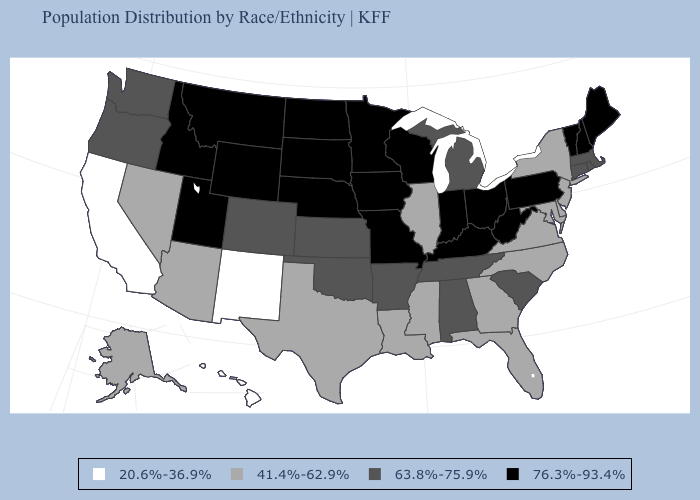Name the states that have a value in the range 41.4%-62.9%?
Answer briefly. Alaska, Arizona, Delaware, Florida, Georgia, Illinois, Louisiana, Maryland, Mississippi, Nevada, New Jersey, New York, North Carolina, Texas, Virginia. What is the highest value in the USA?
Be succinct. 76.3%-93.4%. Does the first symbol in the legend represent the smallest category?
Quick response, please. Yes. What is the value of Kentucky?
Be succinct. 76.3%-93.4%. Does Washington have the highest value in the USA?
Answer briefly. No. Does North Dakota have the highest value in the USA?
Short answer required. Yes. Which states have the lowest value in the USA?
Short answer required. California, Hawaii, New Mexico. Name the states that have a value in the range 41.4%-62.9%?
Quick response, please. Alaska, Arizona, Delaware, Florida, Georgia, Illinois, Louisiana, Maryland, Mississippi, Nevada, New Jersey, New York, North Carolina, Texas, Virginia. What is the value of Illinois?
Give a very brief answer. 41.4%-62.9%. Does Maryland have a higher value than Rhode Island?
Answer briefly. No. Among the states that border Nebraska , does Wyoming have the lowest value?
Concise answer only. No. Among the states that border Kentucky , does West Virginia have the lowest value?
Give a very brief answer. No. What is the value of Iowa?
Answer briefly. 76.3%-93.4%. Name the states that have a value in the range 41.4%-62.9%?
Quick response, please. Alaska, Arizona, Delaware, Florida, Georgia, Illinois, Louisiana, Maryland, Mississippi, Nevada, New Jersey, New York, North Carolina, Texas, Virginia. Name the states that have a value in the range 76.3%-93.4%?
Concise answer only. Idaho, Indiana, Iowa, Kentucky, Maine, Minnesota, Missouri, Montana, Nebraska, New Hampshire, North Dakota, Ohio, Pennsylvania, South Dakota, Utah, Vermont, West Virginia, Wisconsin, Wyoming. 